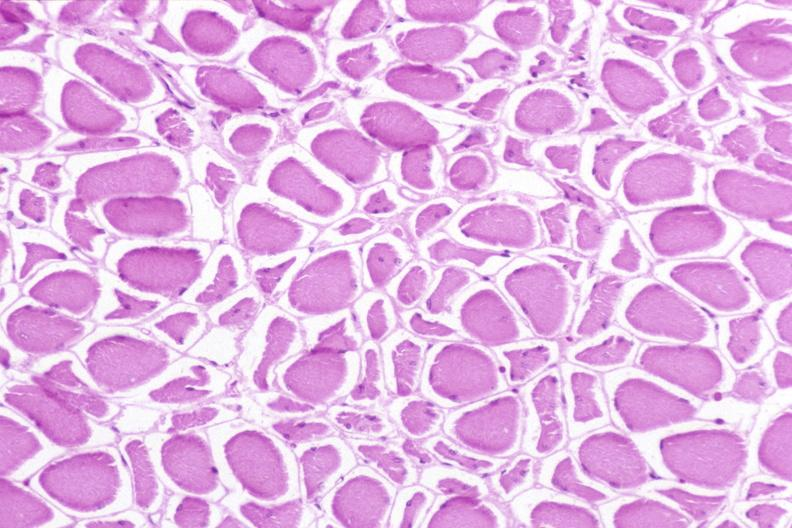does this image show skeletal muscle, atrophy due to immobilization cast?
Answer the question using a single word or phrase. Yes 